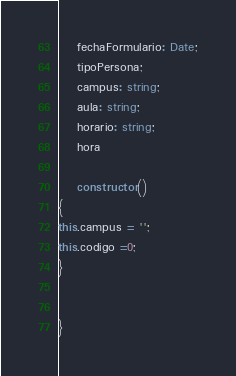Convert code to text. <code><loc_0><loc_0><loc_500><loc_500><_TypeScript_>    fechaFormulario: Date;
    tipoPersona;
    campus: string;
    aula: string;
    horario: string;
    hora

    constructor()
{
this.campus = '';
this.codigo =0;
}


}</code> 